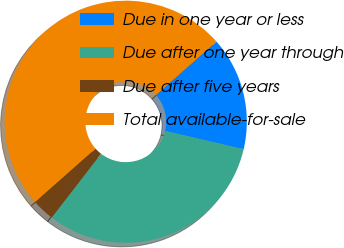Convert chart to OTSL. <chart><loc_0><loc_0><loc_500><loc_500><pie_chart><fcel>Due in one year or less<fcel>Due after one year through<fcel>Due after five years<fcel>Total available-for-sale<nl><fcel>15.16%<fcel>31.83%<fcel>3.0%<fcel>50.0%<nl></chart> 